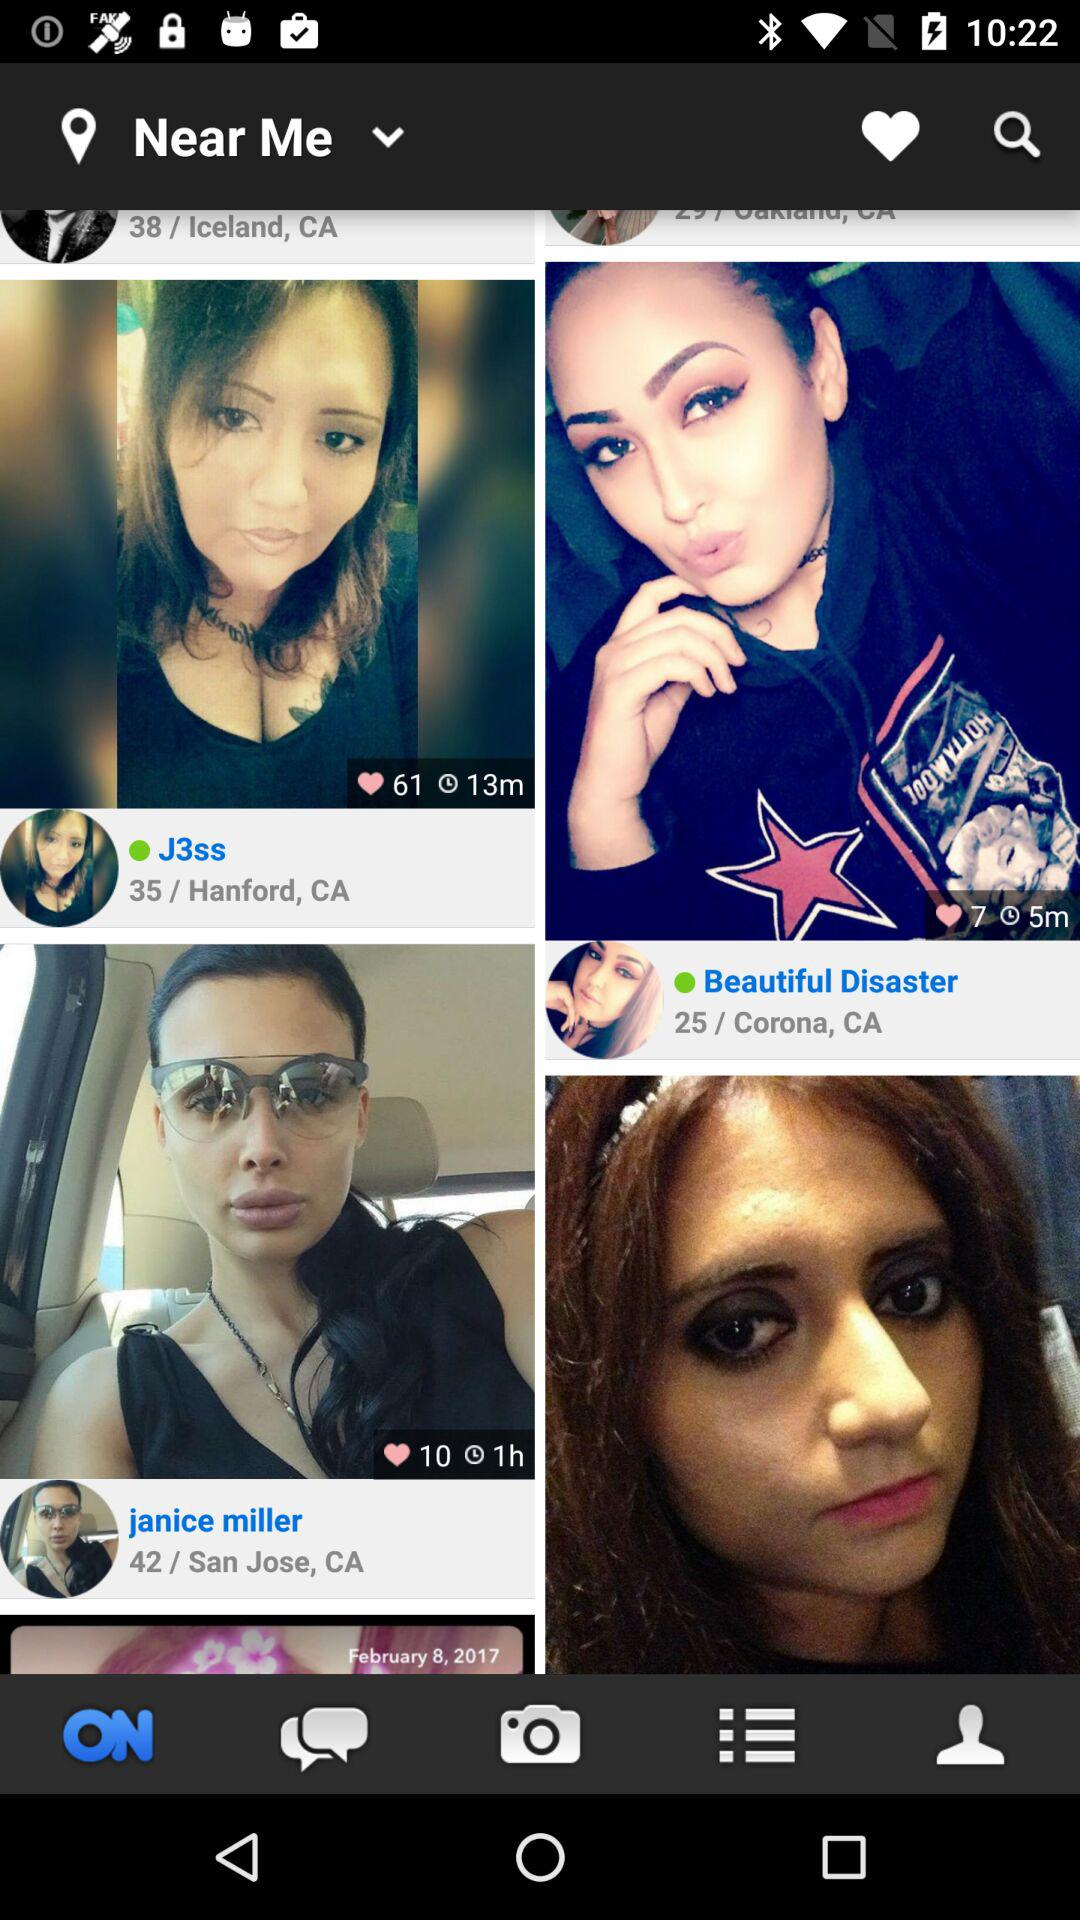How many likes are on the post by Beautiful Disaster? There are 7 likes on the post by Beautiful Disaster. 